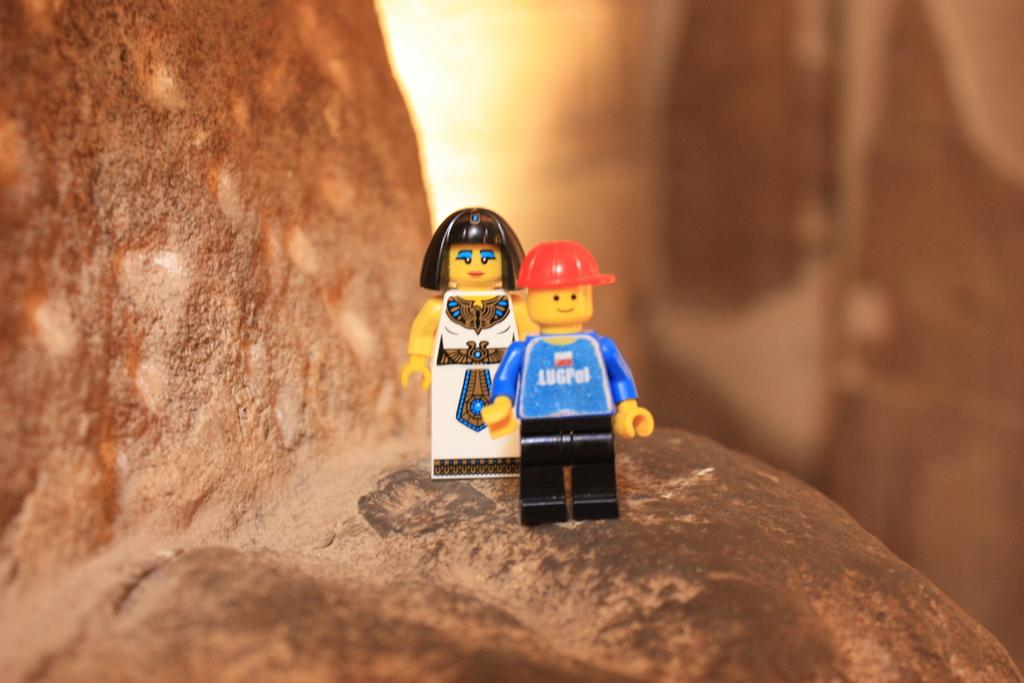How many toys are present in the image? There are two toys in the image. Where are the toys placed? The toys are kept on a rock. What is the color of the rock? The rock is in brown color. What can be observed about the background of the image? The background of the image is blurred. What is the appearance of one of the toys? One of the toys has a red cap. What type of rhythm can be heard from the toys in the image? There is no sound or rhythm associated with the toys in the image; they are inanimate objects. 